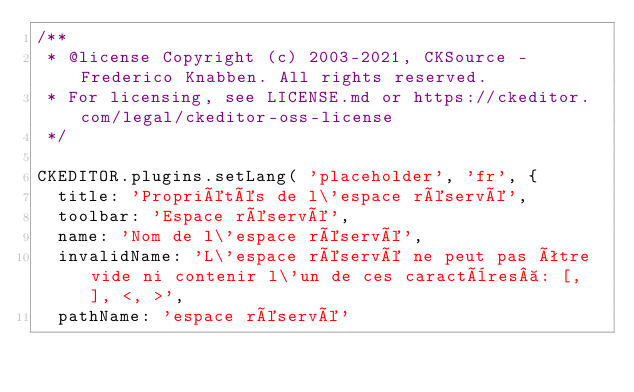Convert code to text. <code><loc_0><loc_0><loc_500><loc_500><_JavaScript_>/**
 * @license Copyright (c) 2003-2021, CKSource - Frederico Knabben. All rights reserved.
 * For licensing, see LICENSE.md or https://ckeditor.com/legal/ckeditor-oss-license
 */

CKEDITOR.plugins.setLang( 'placeholder', 'fr', {
	title: 'Propriétés de l\'espace réservé',
	toolbar: 'Espace réservé',
	name: 'Nom de l\'espace réservé',
	invalidName: 'L\'espace réservé ne peut pas être vide ni contenir l\'un de ces caractères : [, ], <, >',
	pathName: 'espace réservé'</code> 